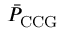Convert formula to latex. <formula><loc_0><loc_0><loc_500><loc_500>\bar { P } _ { C C G }</formula> 